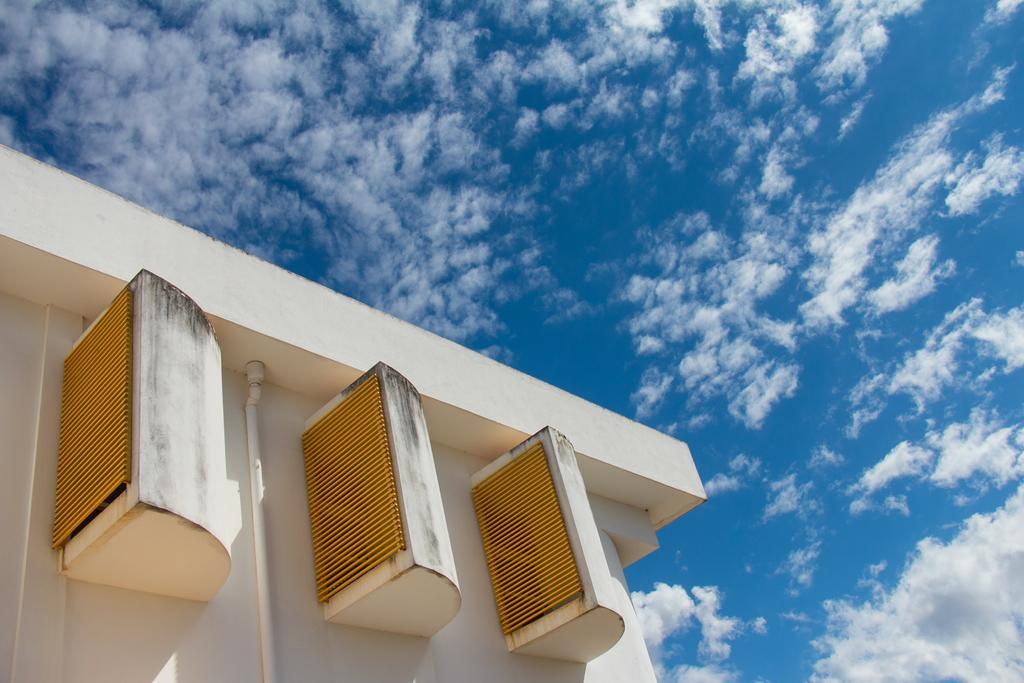In one or two sentences, can you explain what this image depicts? On the left we can see a building, to the building they are looking like ventilators. In most of the picture there is sky. 